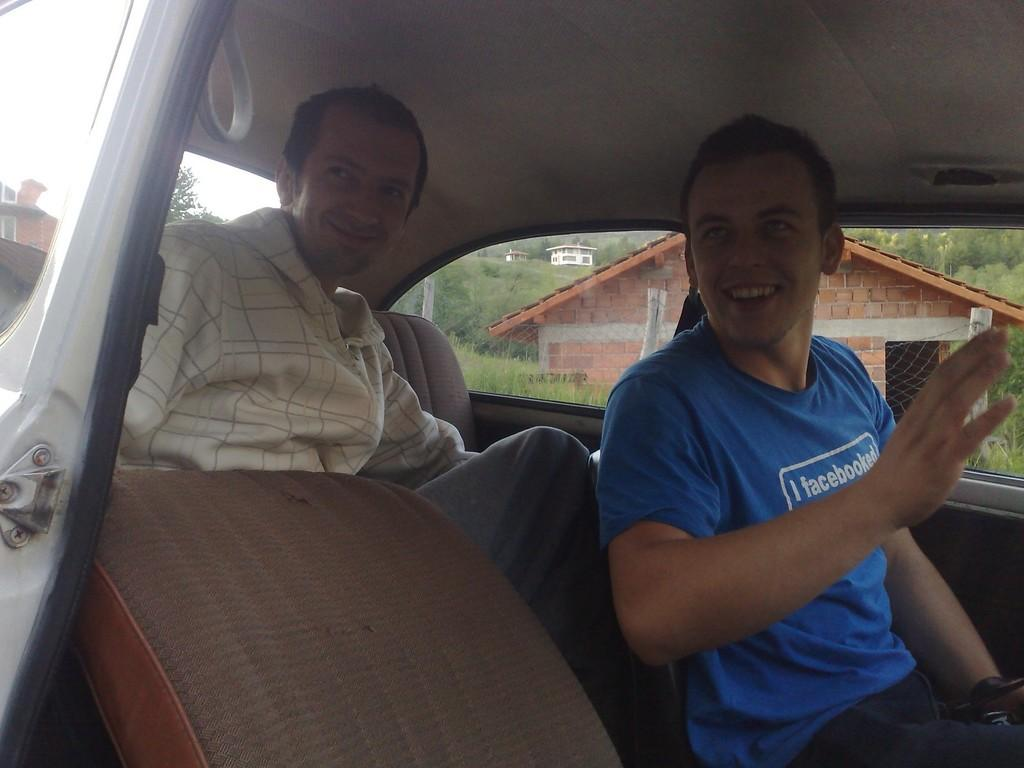How many people are inside the car in the image? There are two people sitting inside the car in the image. What can be seen in the background of the image? Buildings, grass, trees, and the sky are visible in the background of the image. What type of wristwatch is the actor wearing in the image? There is no actor present in the image. 